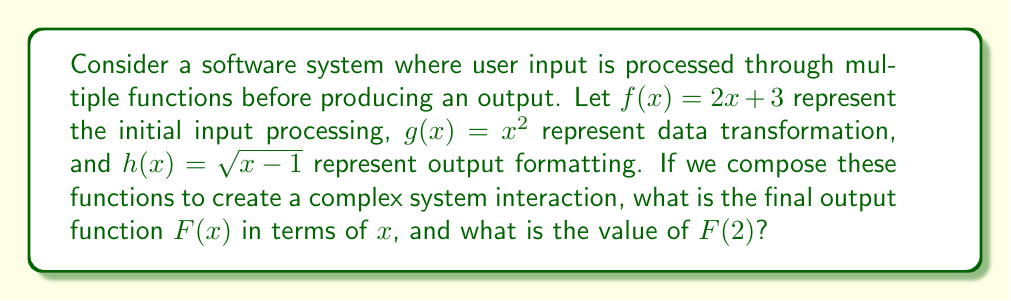Can you solve this math problem? To solve this problem, we need to compose the functions in the order they are applied to the input:

1. Start with the innermost function $f(x) = 2x + 3$
2. Apply $g(x)$ to the result of $f(x)$:
   $g(f(x)) = (2x + 3)^2$
3. Finally, apply $h(x)$ to the result of $g(f(x))$:
   $F(x) = h(g(f(x))) = \sqrt{(2x + 3)^2 - 1}$

Now we have our final output function $F(x) = \sqrt{(2x + 3)^2 - 1}$

To find $F(2)$:
1. Substitute $x = 2$ into $F(x)$:
   $F(2) = \sqrt{(2(2) + 3)^2 - 1}$
2. Simplify inside the parentheses:
   $F(2) = \sqrt{(4 + 3)^2 - 1} = \sqrt{7^2 - 1}$
3. Calculate:
   $F(2) = \sqrt{49 - 1} = \sqrt{48} = 4\sqrt{3}$

Therefore, $F(2) = 4\sqrt{3}$.
Answer: $F(x) = \sqrt{(2x + 3)^2 - 1}$; $F(2) = 4\sqrt{3}$ 